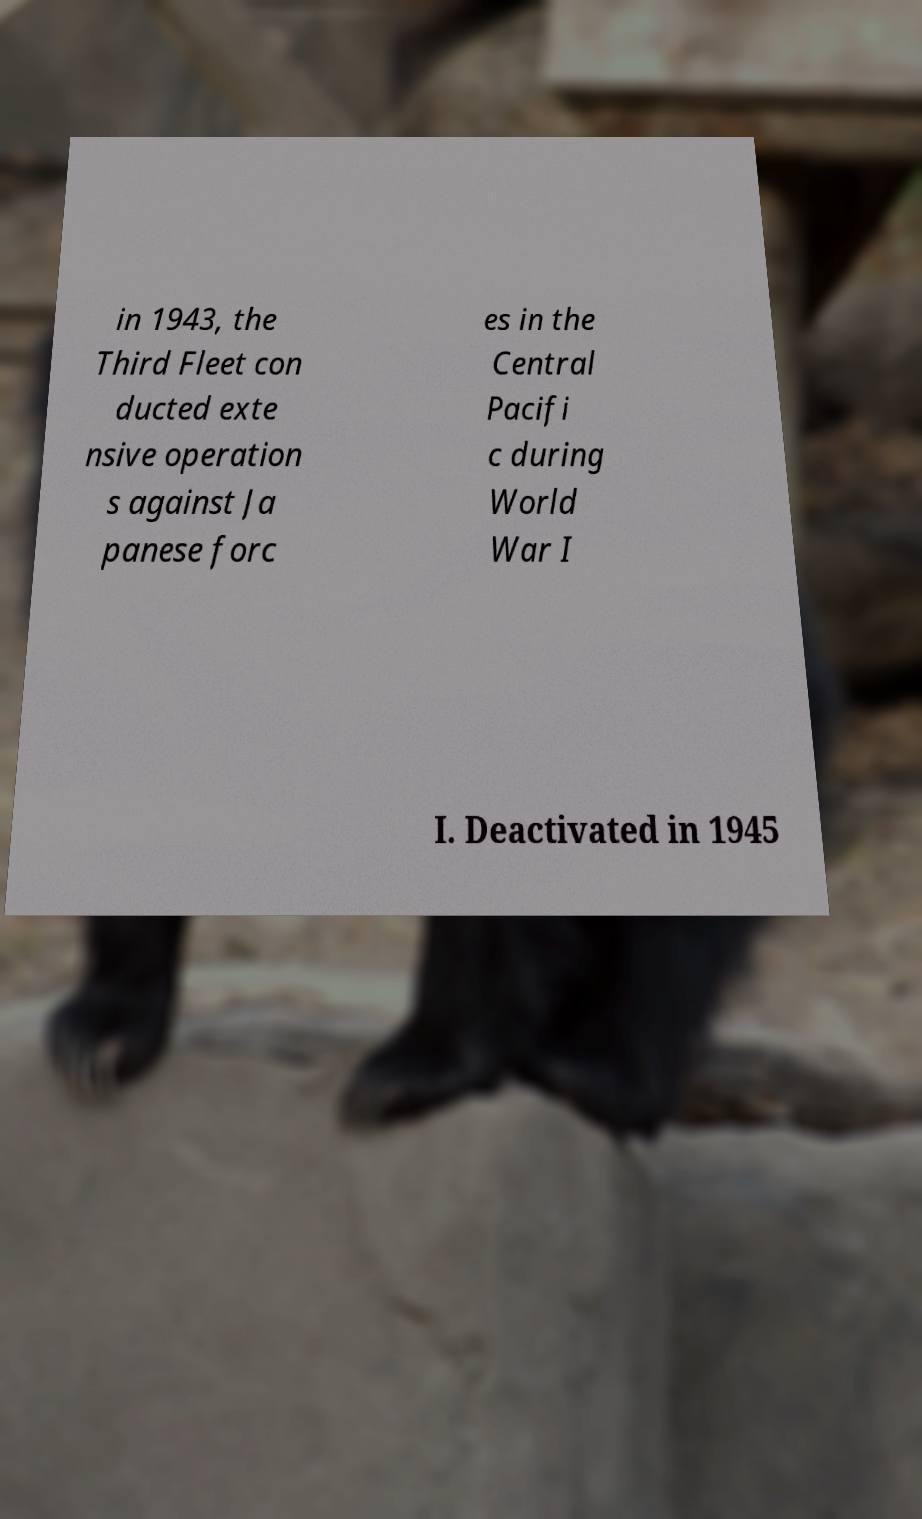I need the written content from this picture converted into text. Can you do that? in 1943, the Third Fleet con ducted exte nsive operation s against Ja panese forc es in the Central Pacifi c during World War I I. Deactivated in 1945 